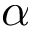<formula> <loc_0><loc_0><loc_500><loc_500>\alpha</formula> 